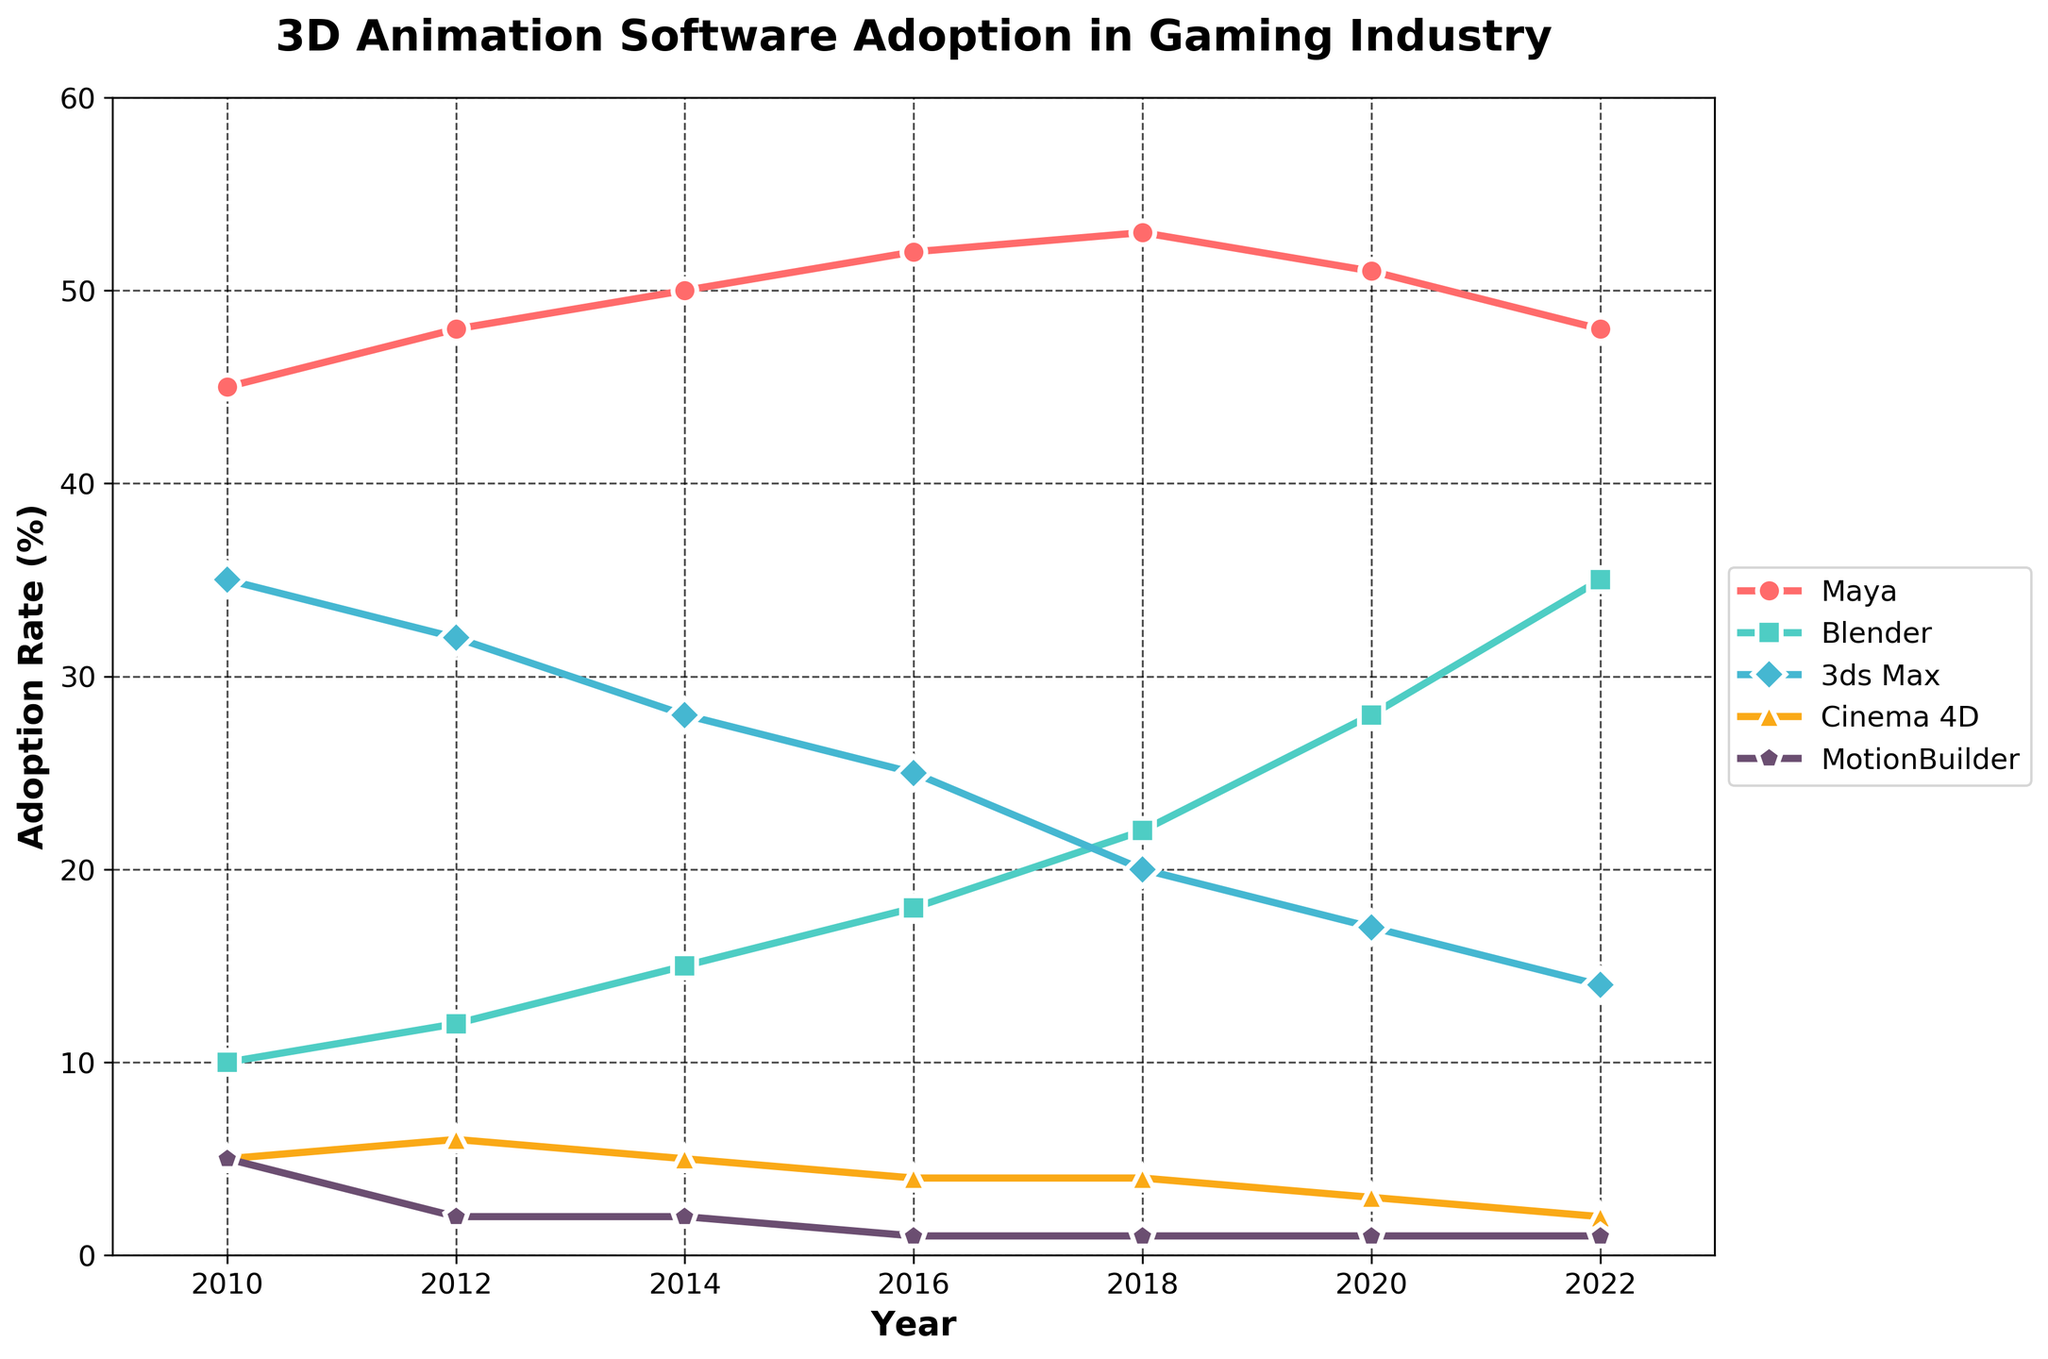What's the most adopted 3D animation software in 2018? Looking at the figure, the line representing Maya is the highest in 2018 with 53%, making it the most adopted software.
Answer: Maya Which software saw the greatest increase in adoption from 2010 to 2022? By evaluating the starting and ending points of each line from 2010 to 2022, Blender's adoption rate increased from 10% to 35%, which is a change of 25%, the largest among all software.
Answer: Blender In which year did 3ds Max experience the most significant drop in adoption rate? 3ds Max's adoption rate line shows the most significant drop between 2018 and 2020, from 20% to 17%, a fall of 3%.
Answer: 2020 How many software had an adoption rate of 5% or less in 2014? The lines for Cinema 4D and MotionBuilder both are at or below 5% in 2014, making them the only two software with adoption rates of 5% or less.
Answer: 2 What is the average adoption rate of all software in 2016? Summing the adoption rates in 2016: 52% (Maya) + 18% (Blender) + 25% (3ds Max) + 4% (Cinema 4D) + 1% (MotionBuilder) = 100%. The average is then 100% / 5 = 20%.
Answer: 20% When did MotionBuilder's adoption rate remain constant over multiple years? MotionBuilder's adoption rate did not change between 2016, 2018, 2020, and 2022, remaining constant at 1%.
Answer: 2016 to 2022 Which two software had the closest adoption rates in 2012? The lines for 3ds Max and Blender in 2012 are closest, with adoption rates of 32% and 12%, respectively. The difference is 20%. The next closest pair has a larger difference.
Answer: 3ds Max and Blender What was the adoption rate difference between Maya and Blender in 2022? In 2022, Maya's rate is 48% and Blender's is 35%, so the difference is
Answer: 13% Which software had a continuous increase in adoption from 2010 to 2020? By examining the slope of each software line, only Blender shows a continuous increase from 2010 to 2020 without any decline.
Answer: Blender 